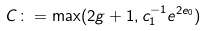<formula> <loc_0><loc_0><loc_500><loc_500>C \colon = \max ( 2 g + 1 , c _ { 1 } ^ { - 1 } e ^ { 2 e _ { 0 } } )</formula> 